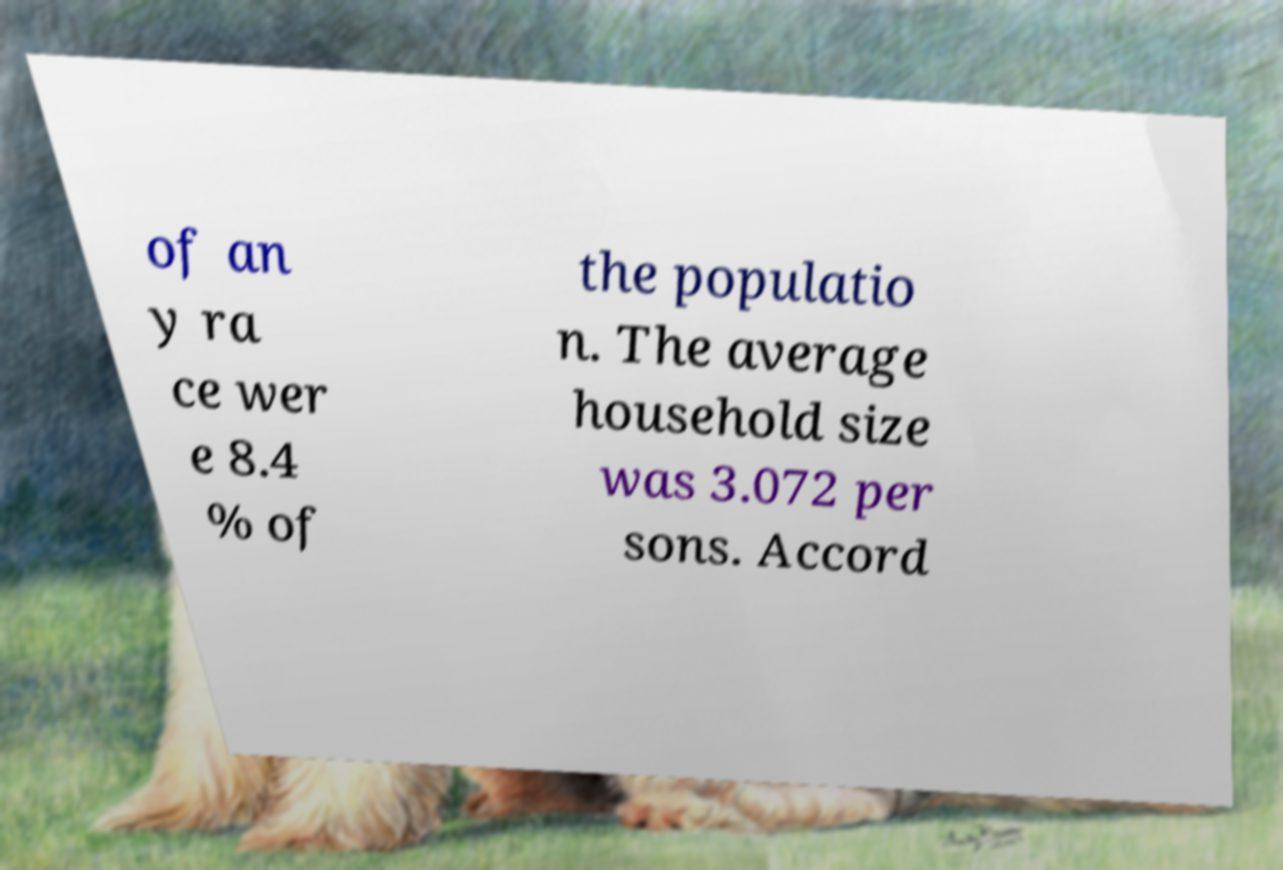Could you extract and type out the text from this image? of an y ra ce wer e 8.4 % of the populatio n. The average household size was 3.072 per sons. Accord 